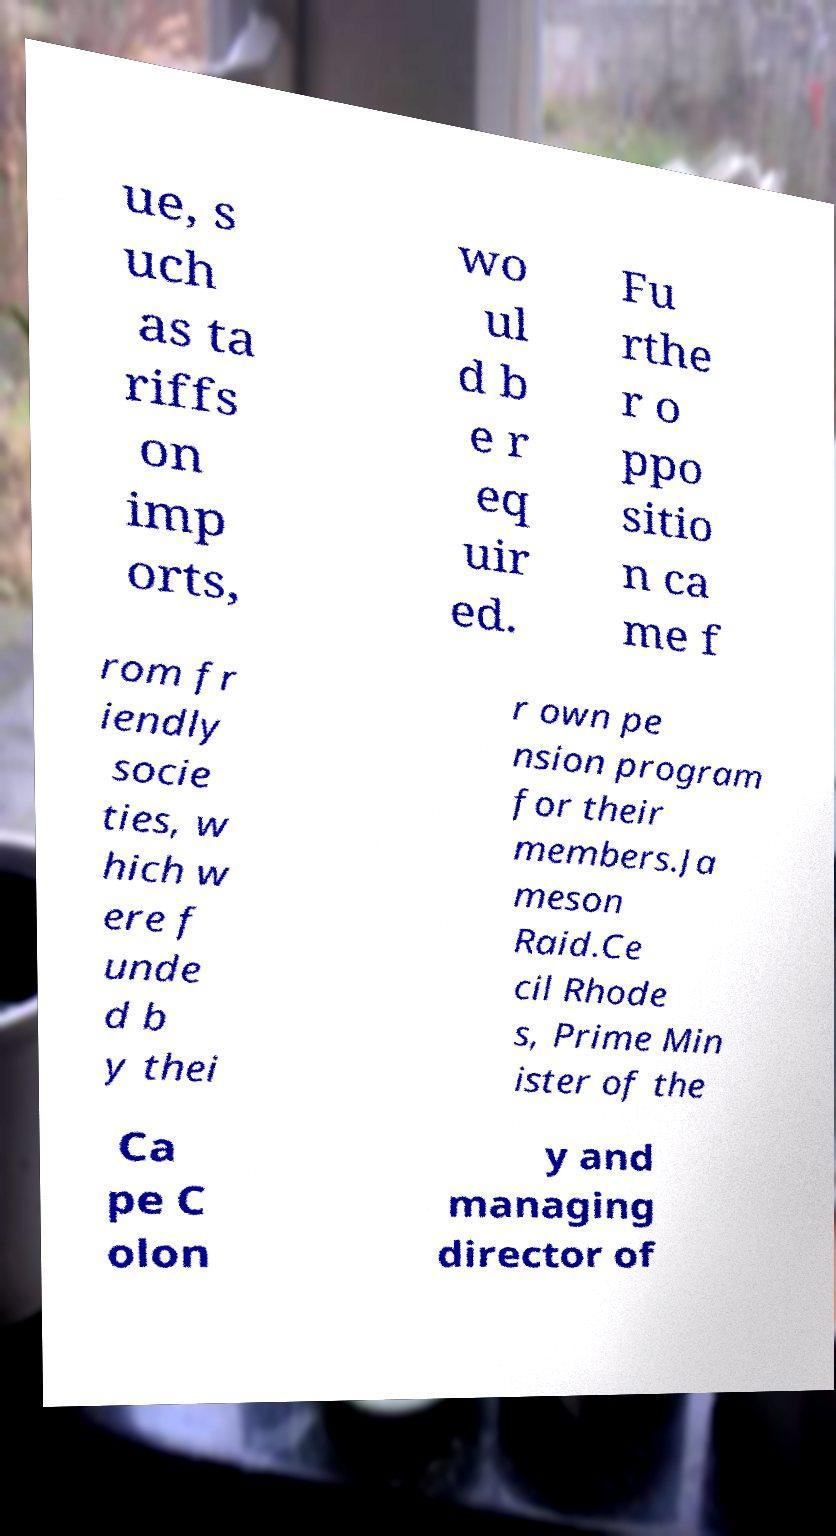I need the written content from this picture converted into text. Can you do that? ue, s uch as ta riffs on imp orts, wo ul d b e r eq uir ed. Fu rthe r o ppo sitio n ca me f rom fr iendly socie ties, w hich w ere f unde d b y thei r own pe nsion program for their members.Ja meson Raid.Ce cil Rhode s, Prime Min ister of the Ca pe C olon y and managing director of 